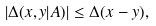<formula> <loc_0><loc_0><loc_500><loc_500>| \Delta ( x , y | A ) | \leq \Delta ( x - y ) ,</formula> 